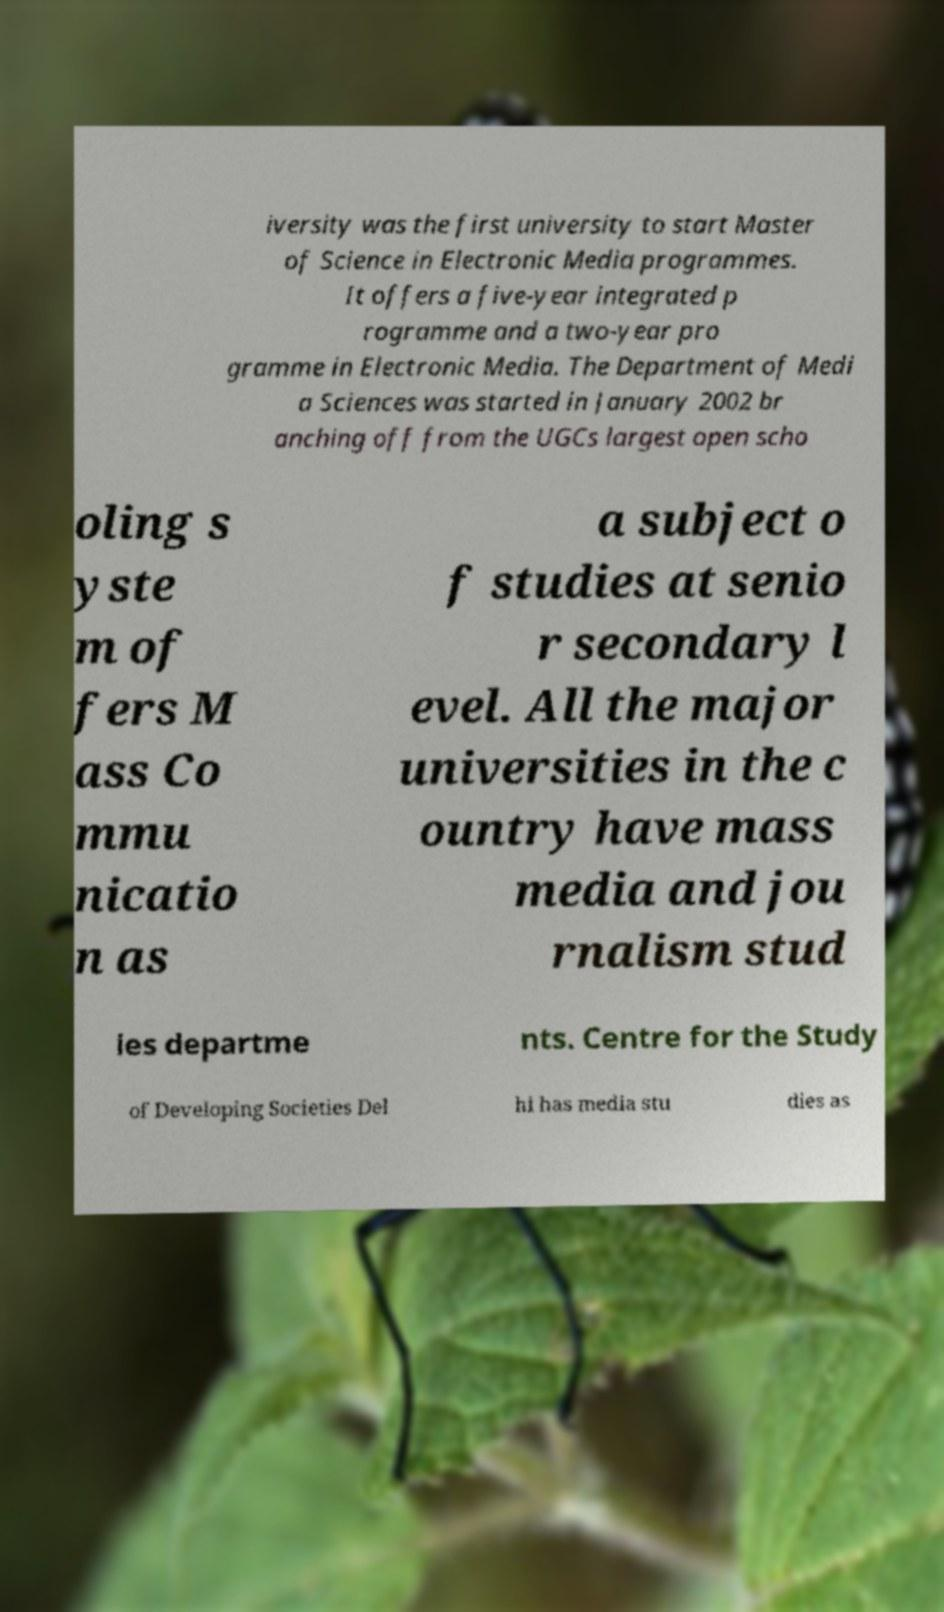There's text embedded in this image that I need extracted. Can you transcribe it verbatim? iversity was the first university to start Master of Science in Electronic Media programmes. It offers a five-year integrated p rogramme and a two-year pro gramme in Electronic Media. The Department of Medi a Sciences was started in January 2002 br anching off from the UGCs largest open scho oling s yste m of fers M ass Co mmu nicatio n as a subject o f studies at senio r secondary l evel. All the major universities in the c ountry have mass media and jou rnalism stud ies departme nts. Centre for the Study of Developing Societies Del hi has media stu dies as 